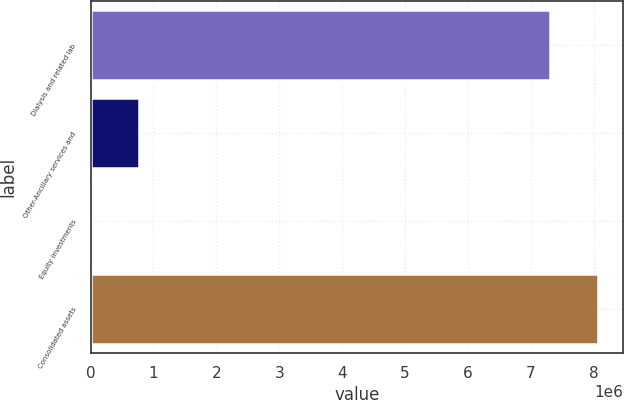Convert chart to OTSL. <chart><loc_0><loc_0><loc_500><loc_500><bar_chart><fcel>Dialysis and related lab<fcel>Other-Ancillary services and<fcel>Equity investments<fcel>Consolidated assets<nl><fcel>7.3116e+06<fcel>776192<fcel>22631<fcel>8.06516e+06<nl></chart> 